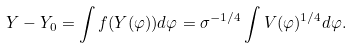Convert formula to latex. <formula><loc_0><loc_0><loc_500><loc_500>Y - Y _ { 0 } = \int f ( Y ( \varphi ) ) d \varphi = \sigma ^ { - 1 / 4 } \int V ( \varphi ) ^ { 1 / 4 } d \varphi .</formula> 